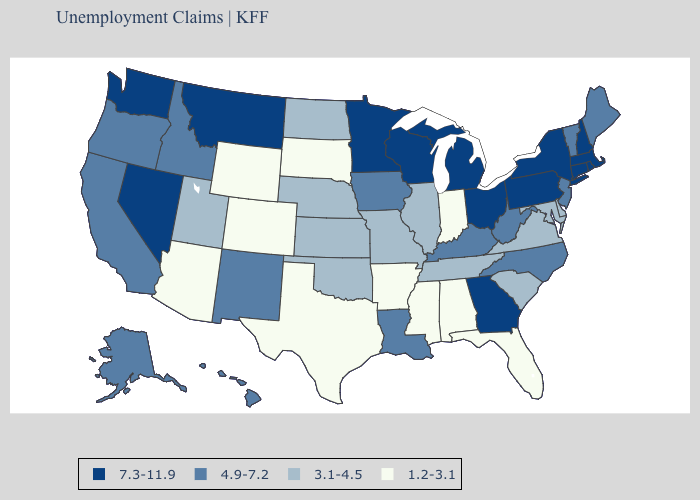Does Virginia have the lowest value in the South?
Write a very short answer. No. What is the value of Colorado?
Be succinct. 1.2-3.1. Name the states that have a value in the range 7.3-11.9?
Concise answer only. Connecticut, Georgia, Massachusetts, Michigan, Minnesota, Montana, Nevada, New Hampshire, New York, Ohio, Pennsylvania, Rhode Island, Washington, Wisconsin. Name the states that have a value in the range 1.2-3.1?
Keep it brief. Alabama, Arizona, Arkansas, Colorado, Florida, Indiana, Mississippi, South Dakota, Texas, Wyoming. Does Missouri have the same value as Rhode Island?
Keep it brief. No. Among the states that border New Mexico , does Arizona have the highest value?
Be succinct. No. What is the highest value in states that border Texas?
Concise answer only. 4.9-7.2. Does Missouri have the same value as Wisconsin?
Quick response, please. No. Does Kansas have the same value as Michigan?
Give a very brief answer. No. Name the states that have a value in the range 4.9-7.2?
Answer briefly. Alaska, California, Hawaii, Idaho, Iowa, Kentucky, Louisiana, Maine, New Jersey, New Mexico, North Carolina, Oregon, Vermont, West Virginia. What is the value of Texas?
Answer briefly. 1.2-3.1. Name the states that have a value in the range 3.1-4.5?
Concise answer only. Delaware, Illinois, Kansas, Maryland, Missouri, Nebraska, North Dakota, Oklahoma, South Carolina, Tennessee, Utah, Virginia. Among the states that border South Carolina , does North Carolina have the lowest value?
Keep it brief. Yes. Does Montana have the highest value in the West?
Concise answer only. Yes. What is the lowest value in the USA?
Short answer required. 1.2-3.1. 